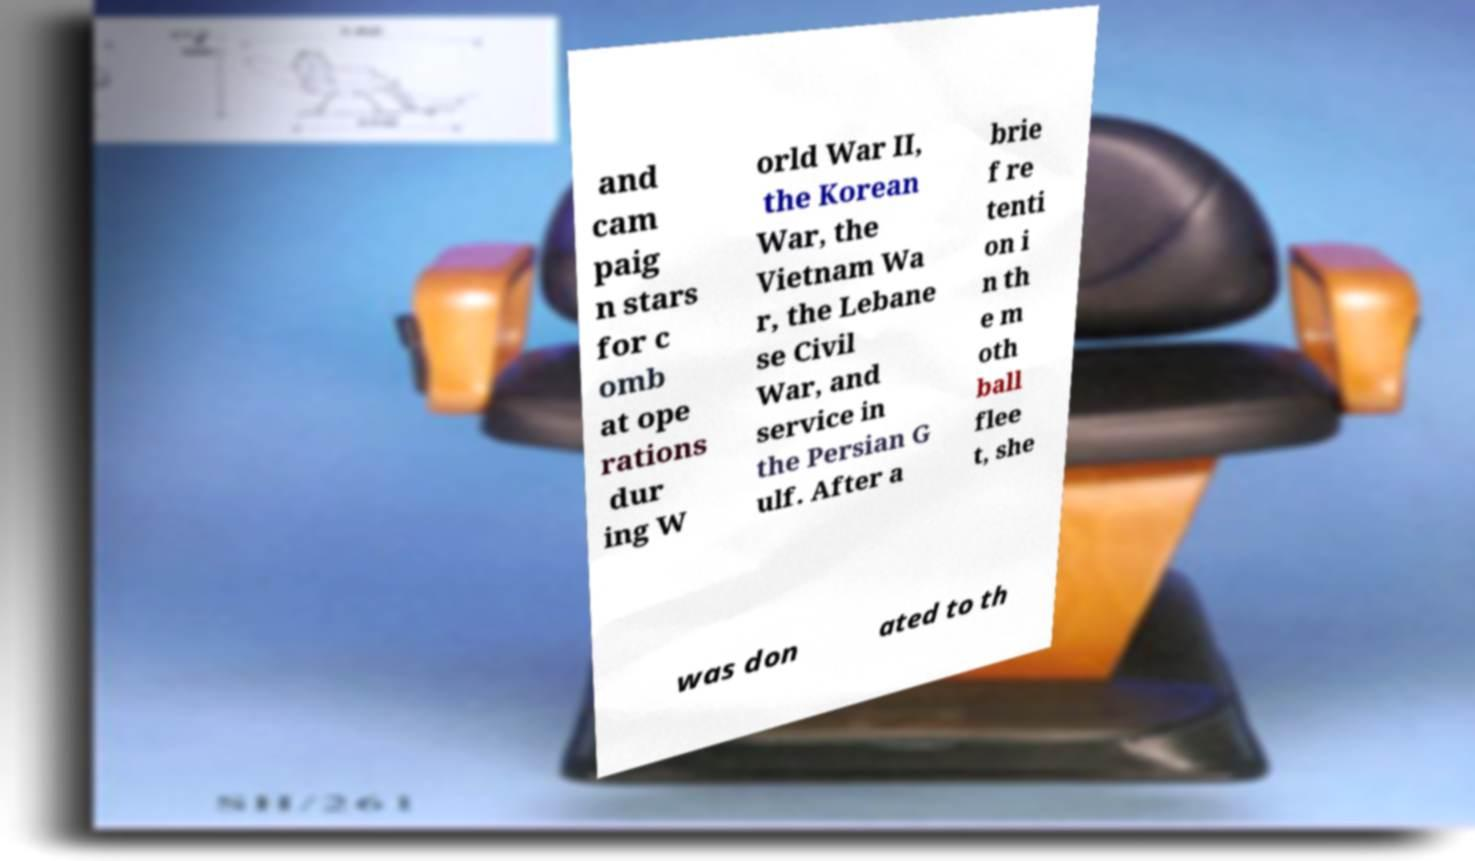Please identify and transcribe the text found in this image. and cam paig n stars for c omb at ope rations dur ing W orld War II, the Korean War, the Vietnam Wa r, the Lebane se Civil War, and service in the Persian G ulf. After a brie f re tenti on i n th e m oth ball flee t, she was don ated to th 